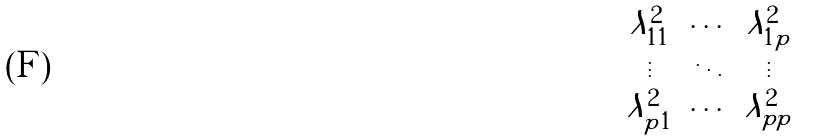<formula> <loc_0><loc_0><loc_500><loc_500>\begin{pmatrix} \lambda ^ { 2 } _ { 1 1 } & \cdots & \lambda ^ { 2 } _ { 1 p } \\ \vdots & \ddots & \vdots \\ \lambda ^ { 2 } _ { p 1 } & \cdots & \lambda ^ { 2 } _ { p p } \end{pmatrix}</formula> 